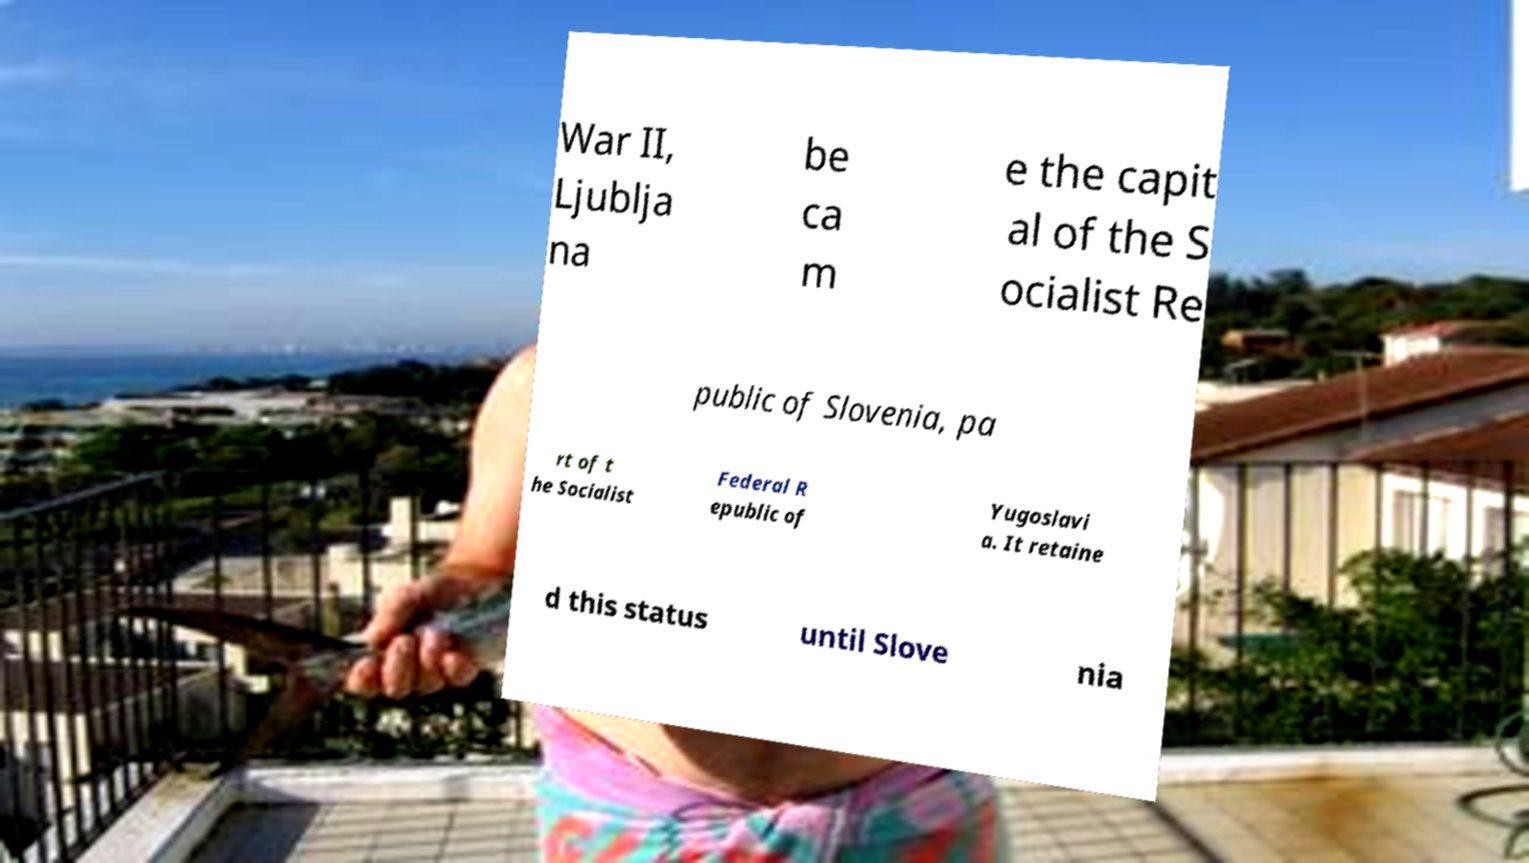Could you assist in decoding the text presented in this image and type it out clearly? War II, Ljublja na be ca m e the capit al of the S ocialist Re public of Slovenia, pa rt of t he Socialist Federal R epublic of Yugoslavi a. It retaine d this status until Slove nia 